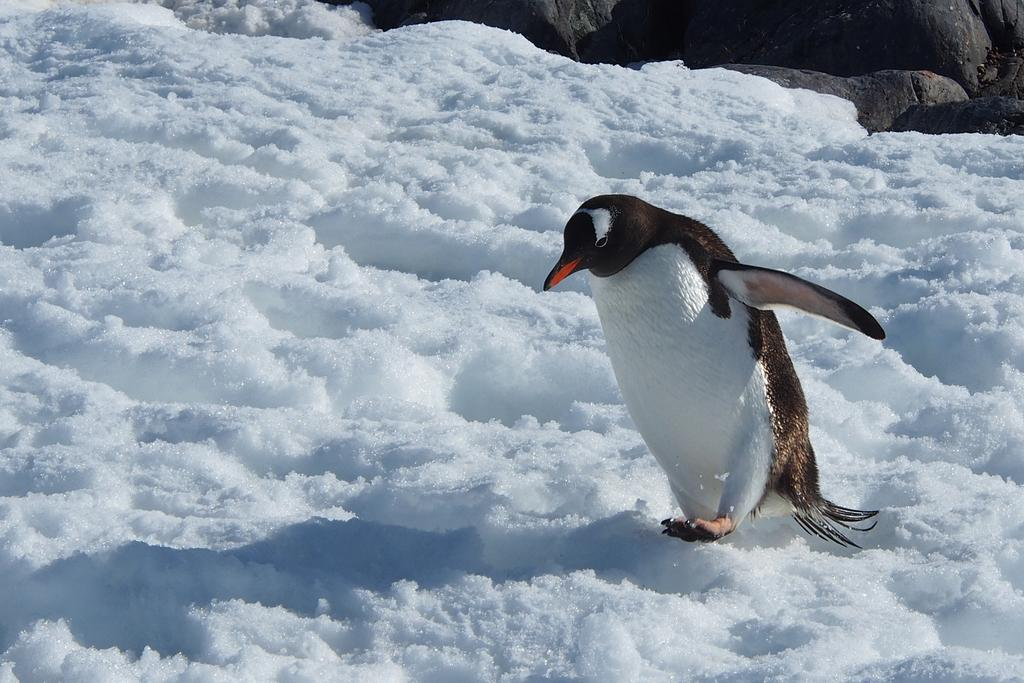What is the predominant weather condition in the image? There is snow in the image, indicating a cold and snowy environment. What animal can be seen in the image? There is a penguin in front of the image. What color objects are present in the background of the image? There are black color things in the background of the image. What type of voice does the penguin have in the image? Penguins do not have a voice in the image, as it is a still photograph and does not capture sound. 